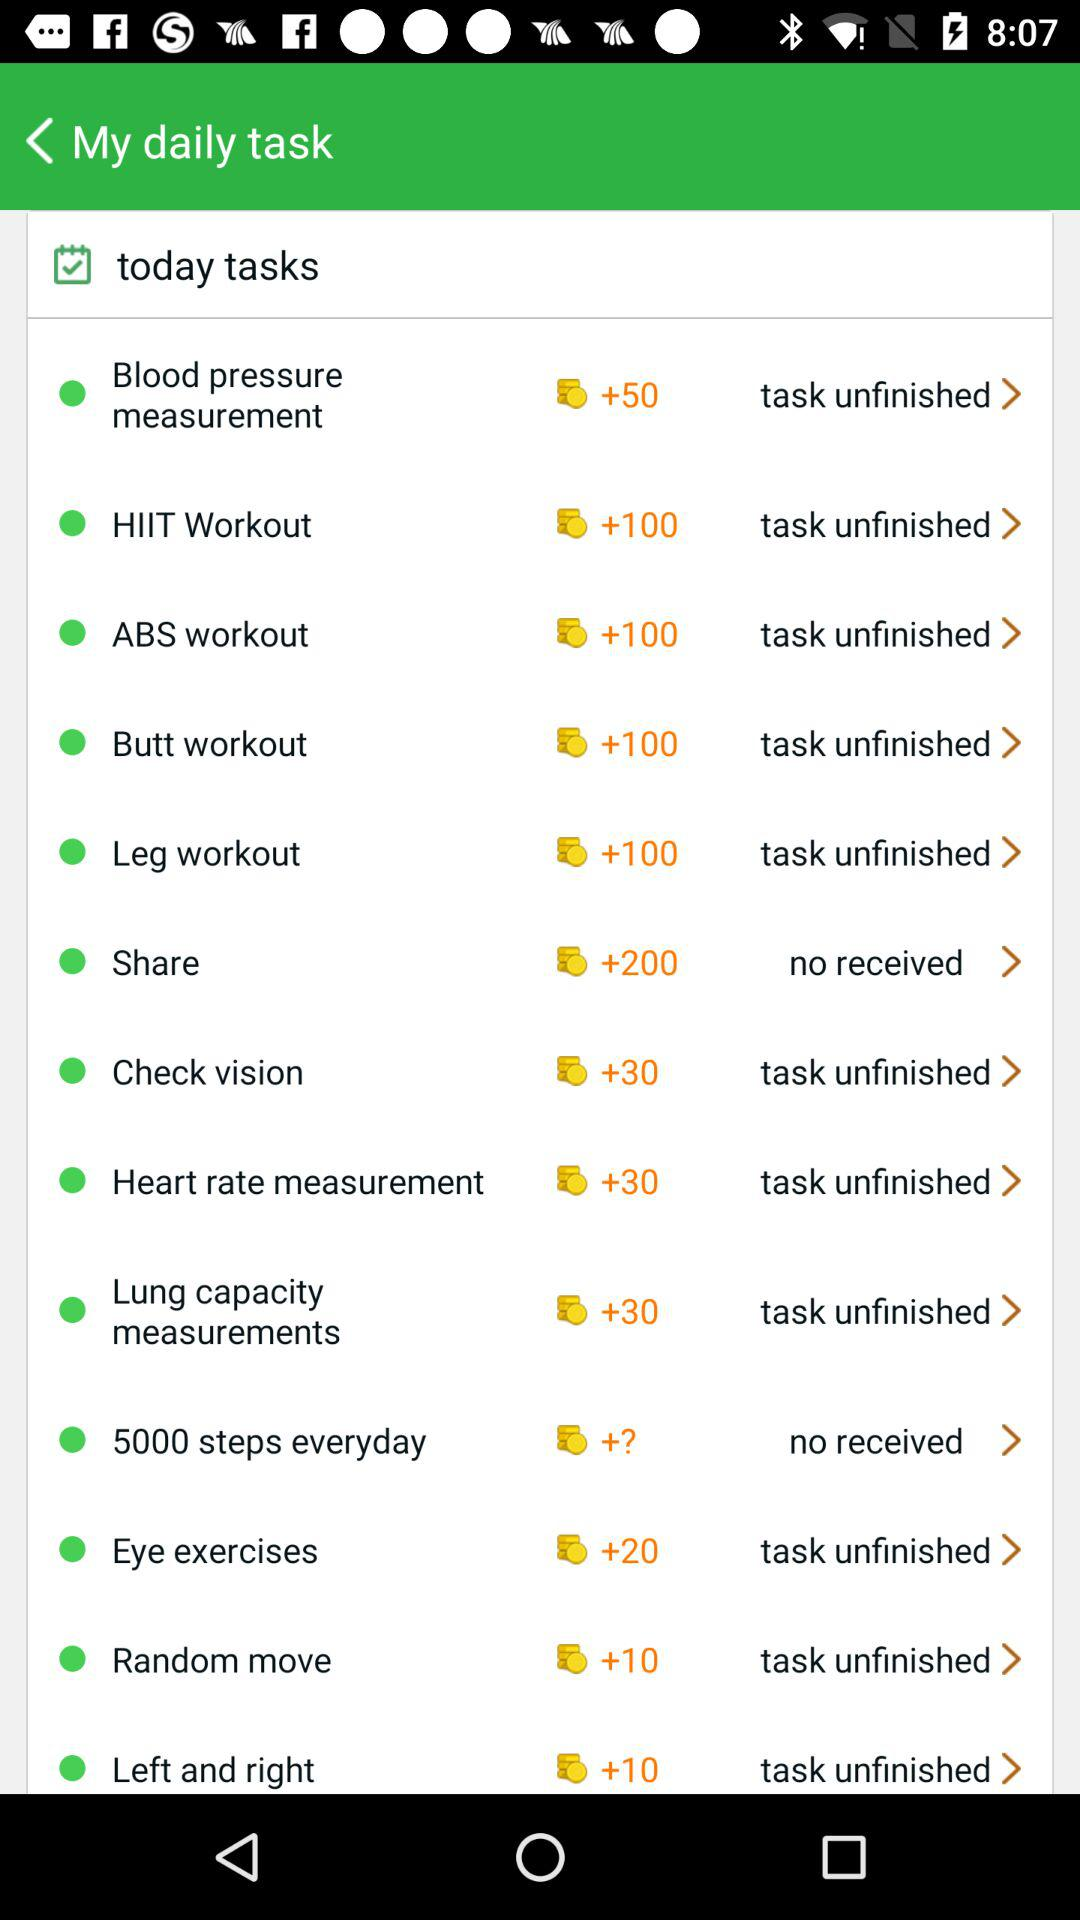Which tasks are not finished yet? The unfinished tasks are "Blood pressure measurement", "HIIT Workout", "ABS workout", "Butt workout", "Leg workout", "Check vision", "Heart rate measurement", "Lung capacity measurements", "Eye exercises", "Random move" and "Left and right". 